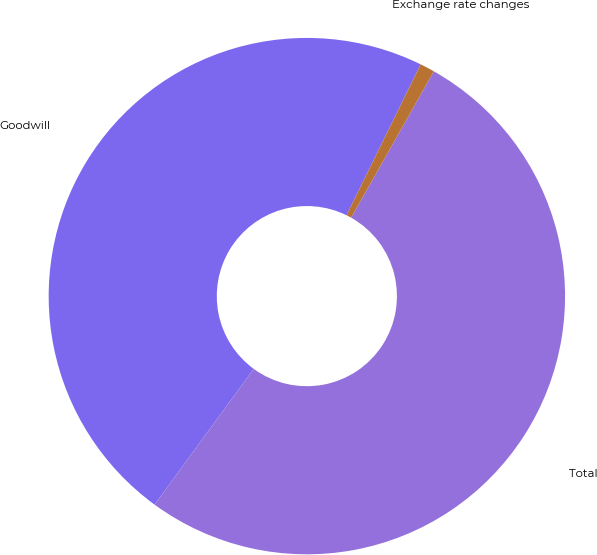Convert chart to OTSL. <chart><loc_0><loc_0><loc_500><loc_500><pie_chart><fcel>Goodwill<fcel>Total<fcel>Exchange rate changes<nl><fcel>47.23%<fcel>51.86%<fcel>0.92%<nl></chart> 